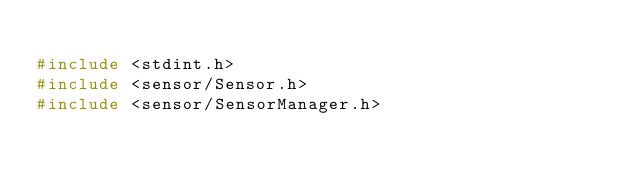<code> <loc_0><loc_0><loc_500><loc_500><_C++_>
#include <stdint.h>
#include <sensor/Sensor.h>
#include <sensor/SensorManager.h></code> 